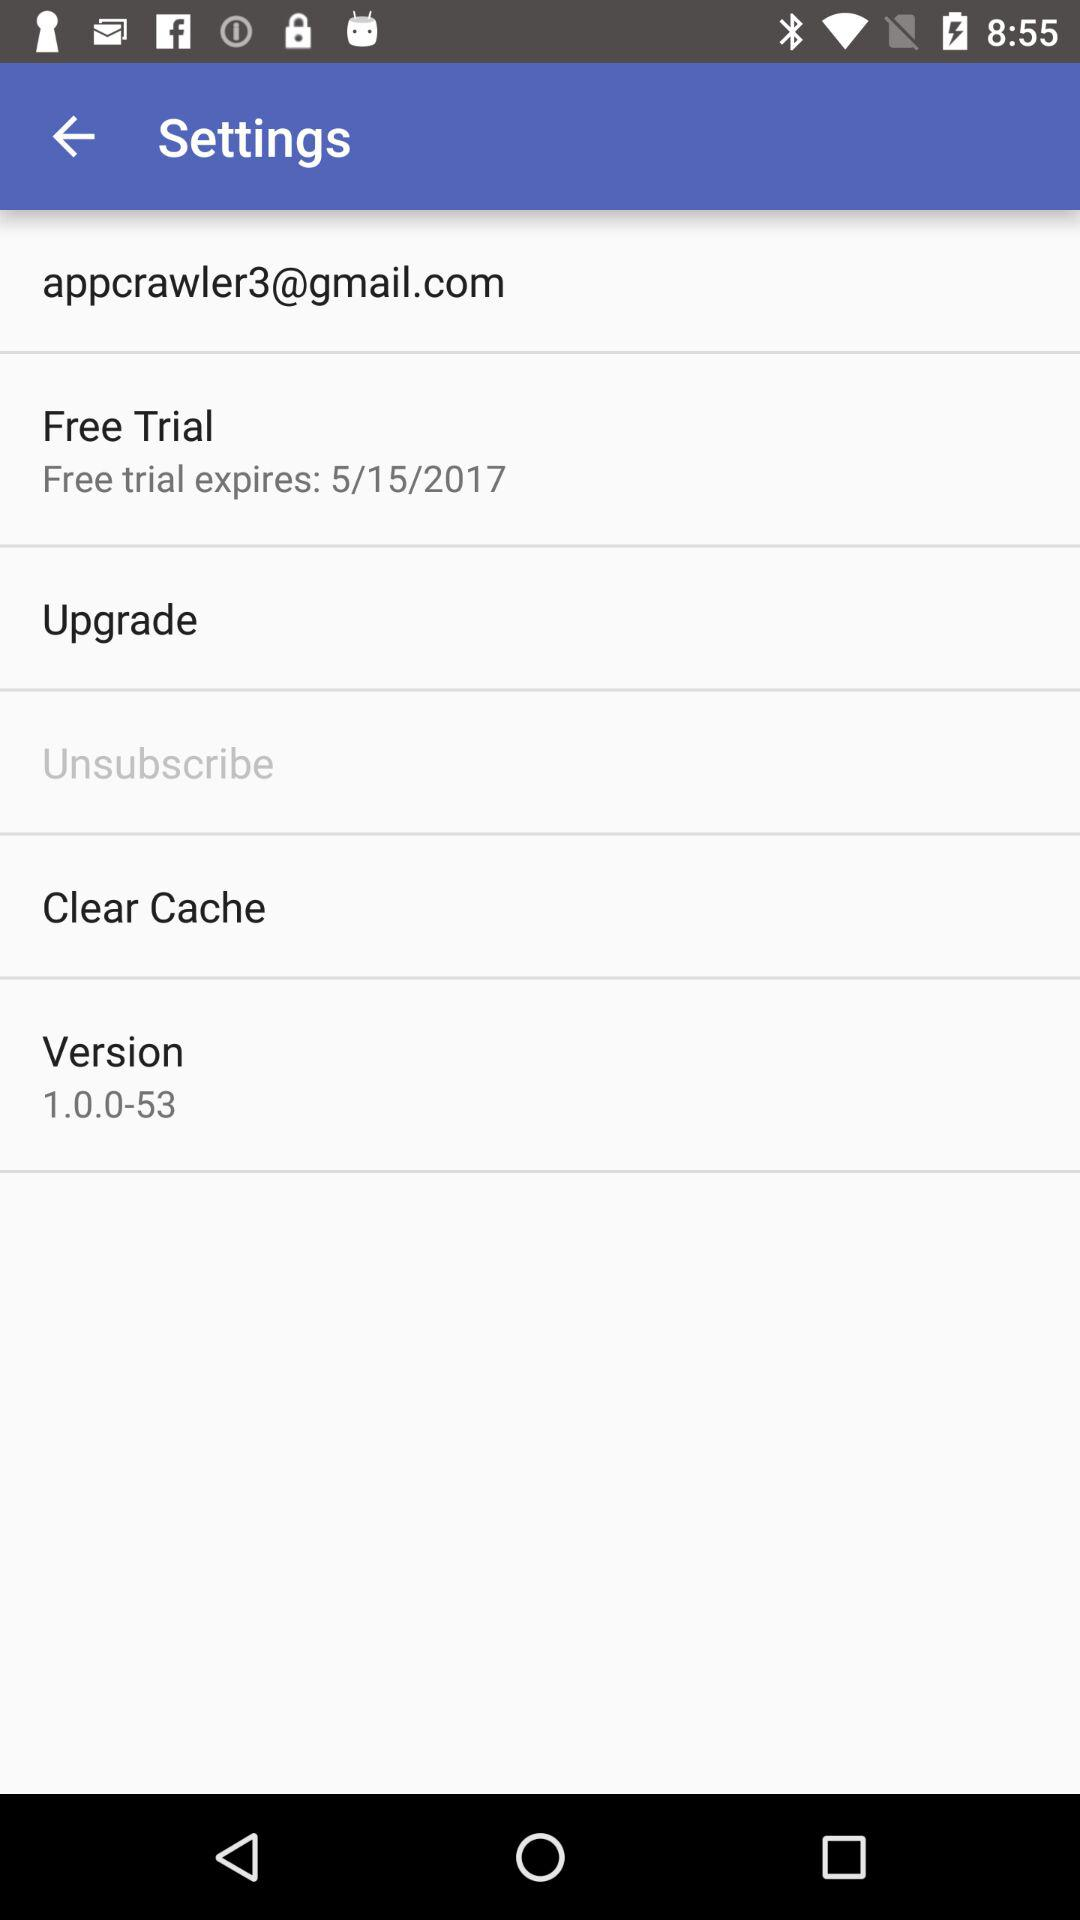When did the trial period end? The trial period ended on May 15, 2017. 